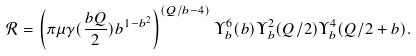<formula> <loc_0><loc_0><loc_500><loc_500>\mathcal { R } = \left ( \pi \mu \gamma ( \frac { b Q } { 2 } ) b ^ { 1 - b ^ { 2 } } \right ) ^ { ( Q / b - 4 ) } \Upsilon _ { b } ^ { 6 } ( b ) \Upsilon _ { b } ^ { 2 } ( Q / 2 ) \Upsilon _ { b } ^ { 4 } ( Q / 2 + b ) .</formula> 